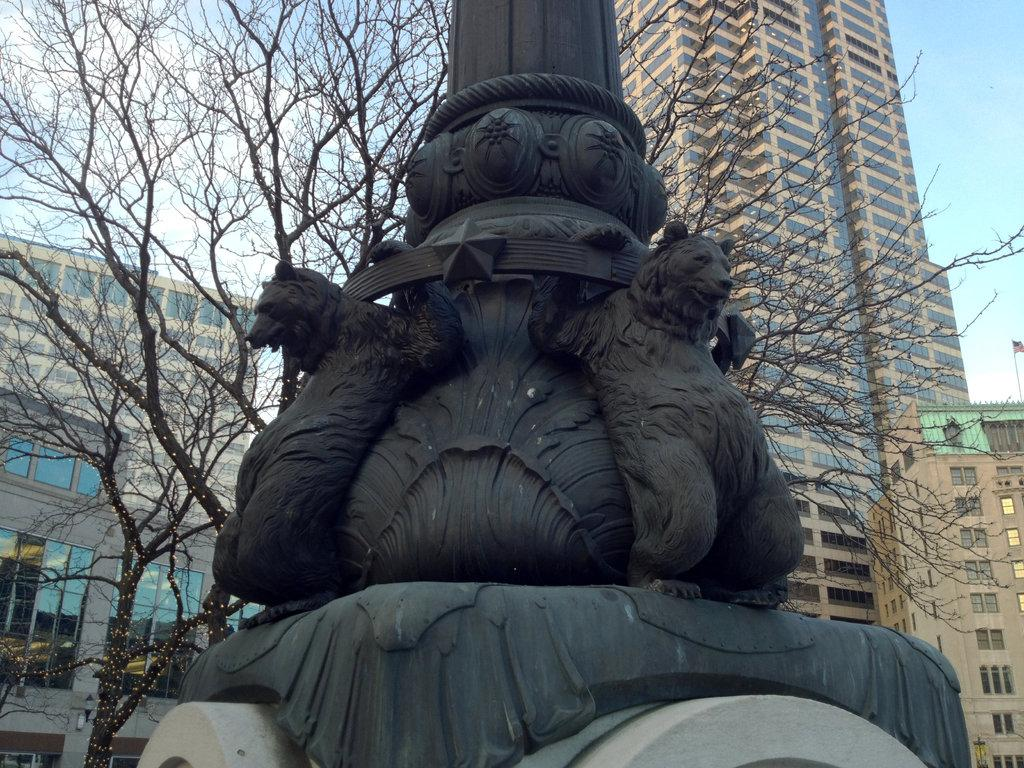What type of structures can be seen in the image? There are buildings in the image. Can you describe a specific part of one of the buildings? There is a window of a building in the image. What type of vegetation is present in the image? There is a tree in the image. What is located on a pole in the image? There is a sculpture on a pole in the image. What is the color of the sky in the image? The sky is pale blue in the image. How many pigs are visible in the image? There are no pigs present in the image. What type of shoes are hanging from the tree branches in the image? There are no shoes hanging from tree branches in the image. 